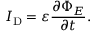Convert formula to latex. <formula><loc_0><loc_0><loc_500><loc_500>I _ { D } = \varepsilon { \frac { \partial \Phi _ { E } } { \partial t } } .</formula> 